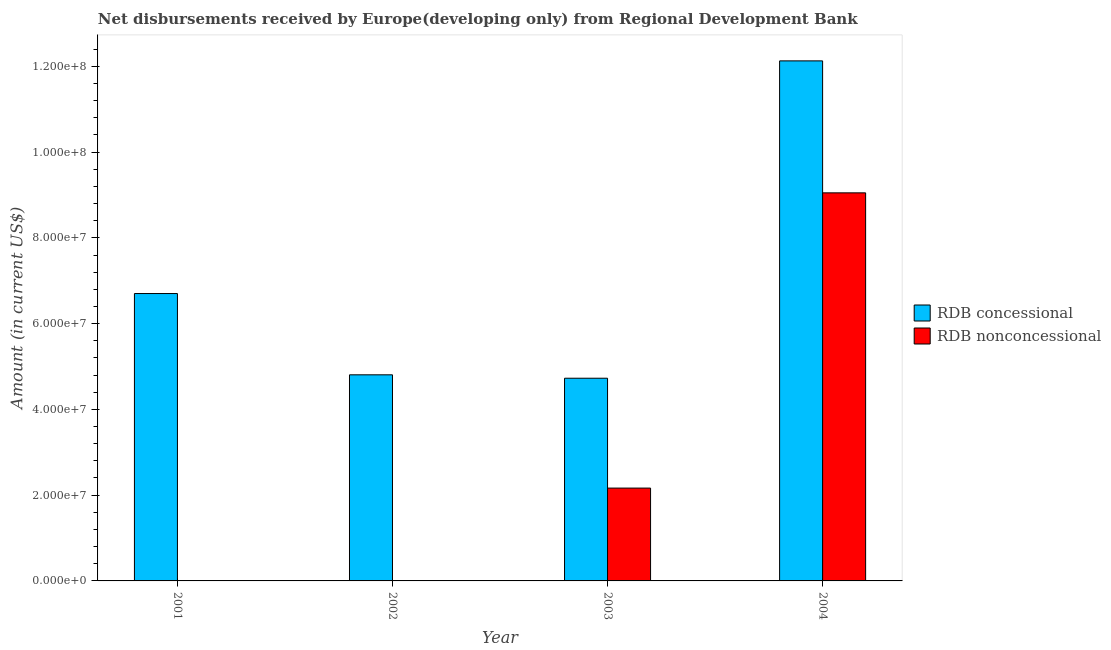How many different coloured bars are there?
Provide a short and direct response. 2. Are the number of bars per tick equal to the number of legend labels?
Give a very brief answer. No. How many bars are there on the 1st tick from the left?
Provide a short and direct response. 1. How many bars are there on the 3rd tick from the right?
Your answer should be very brief. 1. What is the label of the 4th group of bars from the left?
Keep it short and to the point. 2004. In how many cases, is the number of bars for a given year not equal to the number of legend labels?
Offer a very short reply. 2. What is the net non concessional disbursements from rdb in 2001?
Ensure brevity in your answer.  0. Across all years, what is the maximum net non concessional disbursements from rdb?
Offer a very short reply. 9.05e+07. Across all years, what is the minimum net non concessional disbursements from rdb?
Make the answer very short. 0. What is the total net concessional disbursements from rdb in the graph?
Your answer should be compact. 2.84e+08. What is the difference between the net concessional disbursements from rdb in 2001 and that in 2003?
Provide a succinct answer. 1.97e+07. What is the difference between the net non concessional disbursements from rdb in 2004 and the net concessional disbursements from rdb in 2002?
Provide a short and direct response. 9.05e+07. What is the average net non concessional disbursements from rdb per year?
Provide a short and direct response. 2.80e+07. In how many years, is the net concessional disbursements from rdb greater than 24000000 US$?
Provide a short and direct response. 4. What is the ratio of the net concessional disbursements from rdb in 2002 to that in 2003?
Offer a terse response. 1.02. What is the difference between the highest and the second highest net concessional disbursements from rdb?
Provide a succinct answer. 5.43e+07. What is the difference between the highest and the lowest net concessional disbursements from rdb?
Offer a very short reply. 7.40e+07. Is the sum of the net concessional disbursements from rdb in 2001 and 2004 greater than the maximum net non concessional disbursements from rdb across all years?
Your answer should be compact. Yes. How many bars are there?
Provide a succinct answer. 6. Are all the bars in the graph horizontal?
Keep it short and to the point. No. How many years are there in the graph?
Offer a very short reply. 4. Where does the legend appear in the graph?
Offer a very short reply. Center right. How many legend labels are there?
Provide a short and direct response. 2. What is the title of the graph?
Keep it short and to the point. Net disbursements received by Europe(developing only) from Regional Development Bank. Does "Under five" appear as one of the legend labels in the graph?
Your answer should be compact. No. What is the Amount (in current US$) of RDB concessional in 2001?
Your answer should be compact. 6.70e+07. What is the Amount (in current US$) of RDB nonconcessional in 2001?
Provide a succinct answer. 0. What is the Amount (in current US$) of RDB concessional in 2002?
Your answer should be compact. 4.81e+07. What is the Amount (in current US$) in RDB nonconcessional in 2002?
Ensure brevity in your answer.  0. What is the Amount (in current US$) of RDB concessional in 2003?
Provide a succinct answer. 4.73e+07. What is the Amount (in current US$) of RDB nonconcessional in 2003?
Give a very brief answer. 2.16e+07. What is the Amount (in current US$) in RDB concessional in 2004?
Make the answer very short. 1.21e+08. What is the Amount (in current US$) of RDB nonconcessional in 2004?
Your answer should be compact. 9.05e+07. Across all years, what is the maximum Amount (in current US$) in RDB concessional?
Your answer should be compact. 1.21e+08. Across all years, what is the maximum Amount (in current US$) in RDB nonconcessional?
Keep it short and to the point. 9.05e+07. Across all years, what is the minimum Amount (in current US$) of RDB concessional?
Make the answer very short. 4.73e+07. What is the total Amount (in current US$) in RDB concessional in the graph?
Offer a very short reply. 2.84e+08. What is the total Amount (in current US$) of RDB nonconcessional in the graph?
Offer a very short reply. 1.12e+08. What is the difference between the Amount (in current US$) in RDB concessional in 2001 and that in 2002?
Keep it short and to the point. 1.90e+07. What is the difference between the Amount (in current US$) in RDB concessional in 2001 and that in 2003?
Your answer should be compact. 1.97e+07. What is the difference between the Amount (in current US$) in RDB concessional in 2001 and that in 2004?
Offer a terse response. -5.43e+07. What is the difference between the Amount (in current US$) in RDB concessional in 2002 and that in 2003?
Offer a terse response. 7.92e+05. What is the difference between the Amount (in current US$) in RDB concessional in 2002 and that in 2004?
Give a very brief answer. -7.32e+07. What is the difference between the Amount (in current US$) in RDB concessional in 2003 and that in 2004?
Offer a terse response. -7.40e+07. What is the difference between the Amount (in current US$) of RDB nonconcessional in 2003 and that in 2004?
Your answer should be very brief. -6.88e+07. What is the difference between the Amount (in current US$) in RDB concessional in 2001 and the Amount (in current US$) in RDB nonconcessional in 2003?
Your answer should be compact. 4.54e+07. What is the difference between the Amount (in current US$) in RDB concessional in 2001 and the Amount (in current US$) in RDB nonconcessional in 2004?
Give a very brief answer. -2.35e+07. What is the difference between the Amount (in current US$) in RDB concessional in 2002 and the Amount (in current US$) in RDB nonconcessional in 2003?
Provide a short and direct response. 2.64e+07. What is the difference between the Amount (in current US$) of RDB concessional in 2002 and the Amount (in current US$) of RDB nonconcessional in 2004?
Your answer should be very brief. -4.24e+07. What is the difference between the Amount (in current US$) of RDB concessional in 2003 and the Amount (in current US$) of RDB nonconcessional in 2004?
Provide a short and direct response. -4.32e+07. What is the average Amount (in current US$) in RDB concessional per year?
Give a very brief answer. 7.09e+07. What is the average Amount (in current US$) of RDB nonconcessional per year?
Offer a very short reply. 2.80e+07. In the year 2003, what is the difference between the Amount (in current US$) of RDB concessional and Amount (in current US$) of RDB nonconcessional?
Offer a very short reply. 2.56e+07. In the year 2004, what is the difference between the Amount (in current US$) of RDB concessional and Amount (in current US$) of RDB nonconcessional?
Provide a succinct answer. 3.08e+07. What is the ratio of the Amount (in current US$) of RDB concessional in 2001 to that in 2002?
Your answer should be very brief. 1.39. What is the ratio of the Amount (in current US$) in RDB concessional in 2001 to that in 2003?
Offer a very short reply. 1.42. What is the ratio of the Amount (in current US$) in RDB concessional in 2001 to that in 2004?
Offer a very short reply. 0.55. What is the ratio of the Amount (in current US$) of RDB concessional in 2002 to that in 2003?
Offer a very short reply. 1.02. What is the ratio of the Amount (in current US$) of RDB concessional in 2002 to that in 2004?
Provide a succinct answer. 0.4. What is the ratio of the Amount (in current US$) in RDB concessional in 2003 to that in 2004?
Keep it short and to the point. 0.39. What is the ratio of the Amount (in current US$) in RDB nonconcessional in 2003 to that in 2004?
Your answer should be compact. 0.24. What is the difference between the highest and the second highest Amount (in current US$) in RDB concessional?
Provide a short and direct response. 5.43e+07. What is the difference between the highest and the lowest Amount (in current US$) of RDB concessional?
Ensure brevity in your answer.  7.40e+07. What is the difference between the highest and the lowest Amount (in current US$) of RDB nonconcessional?
Keep it short and to the point. 9.05e+07. 